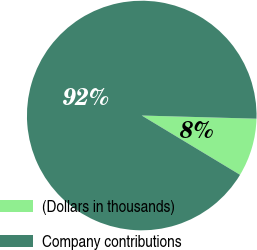<chart> <loc_0><loc_0><loc_500><loc_500><pie_chart><fcel>(Dollars in thousands)<fcel>Company contributions<nl><fcel>8.2%<fcel>91.8%<nl></chart> 